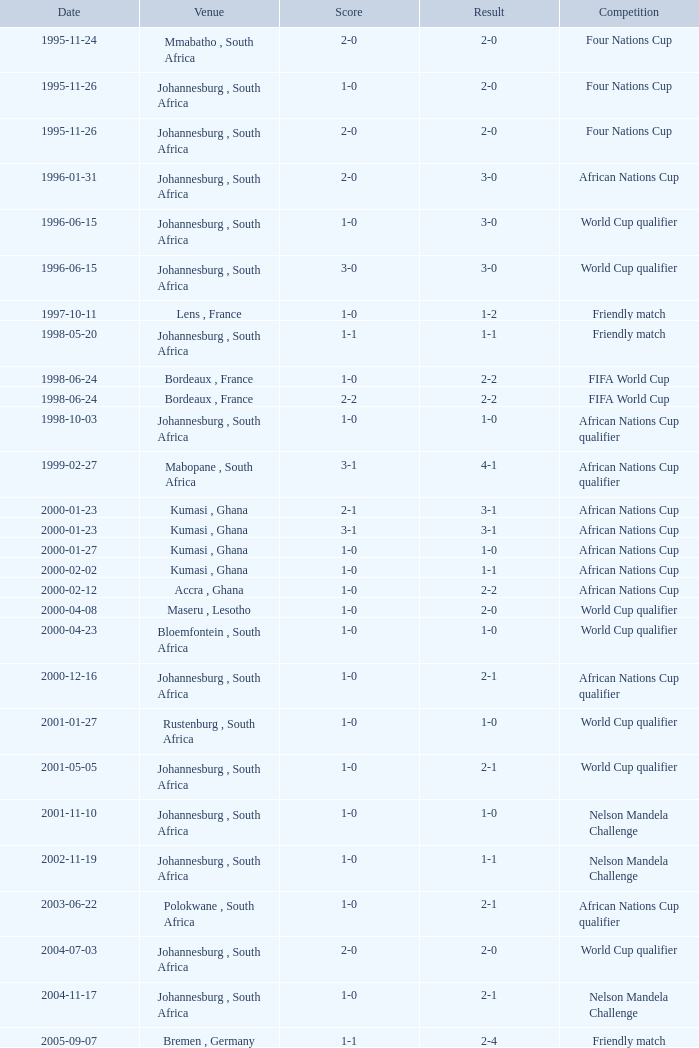What is the date of the fifa world cup with a result of 1-0? 1998-06-24. 